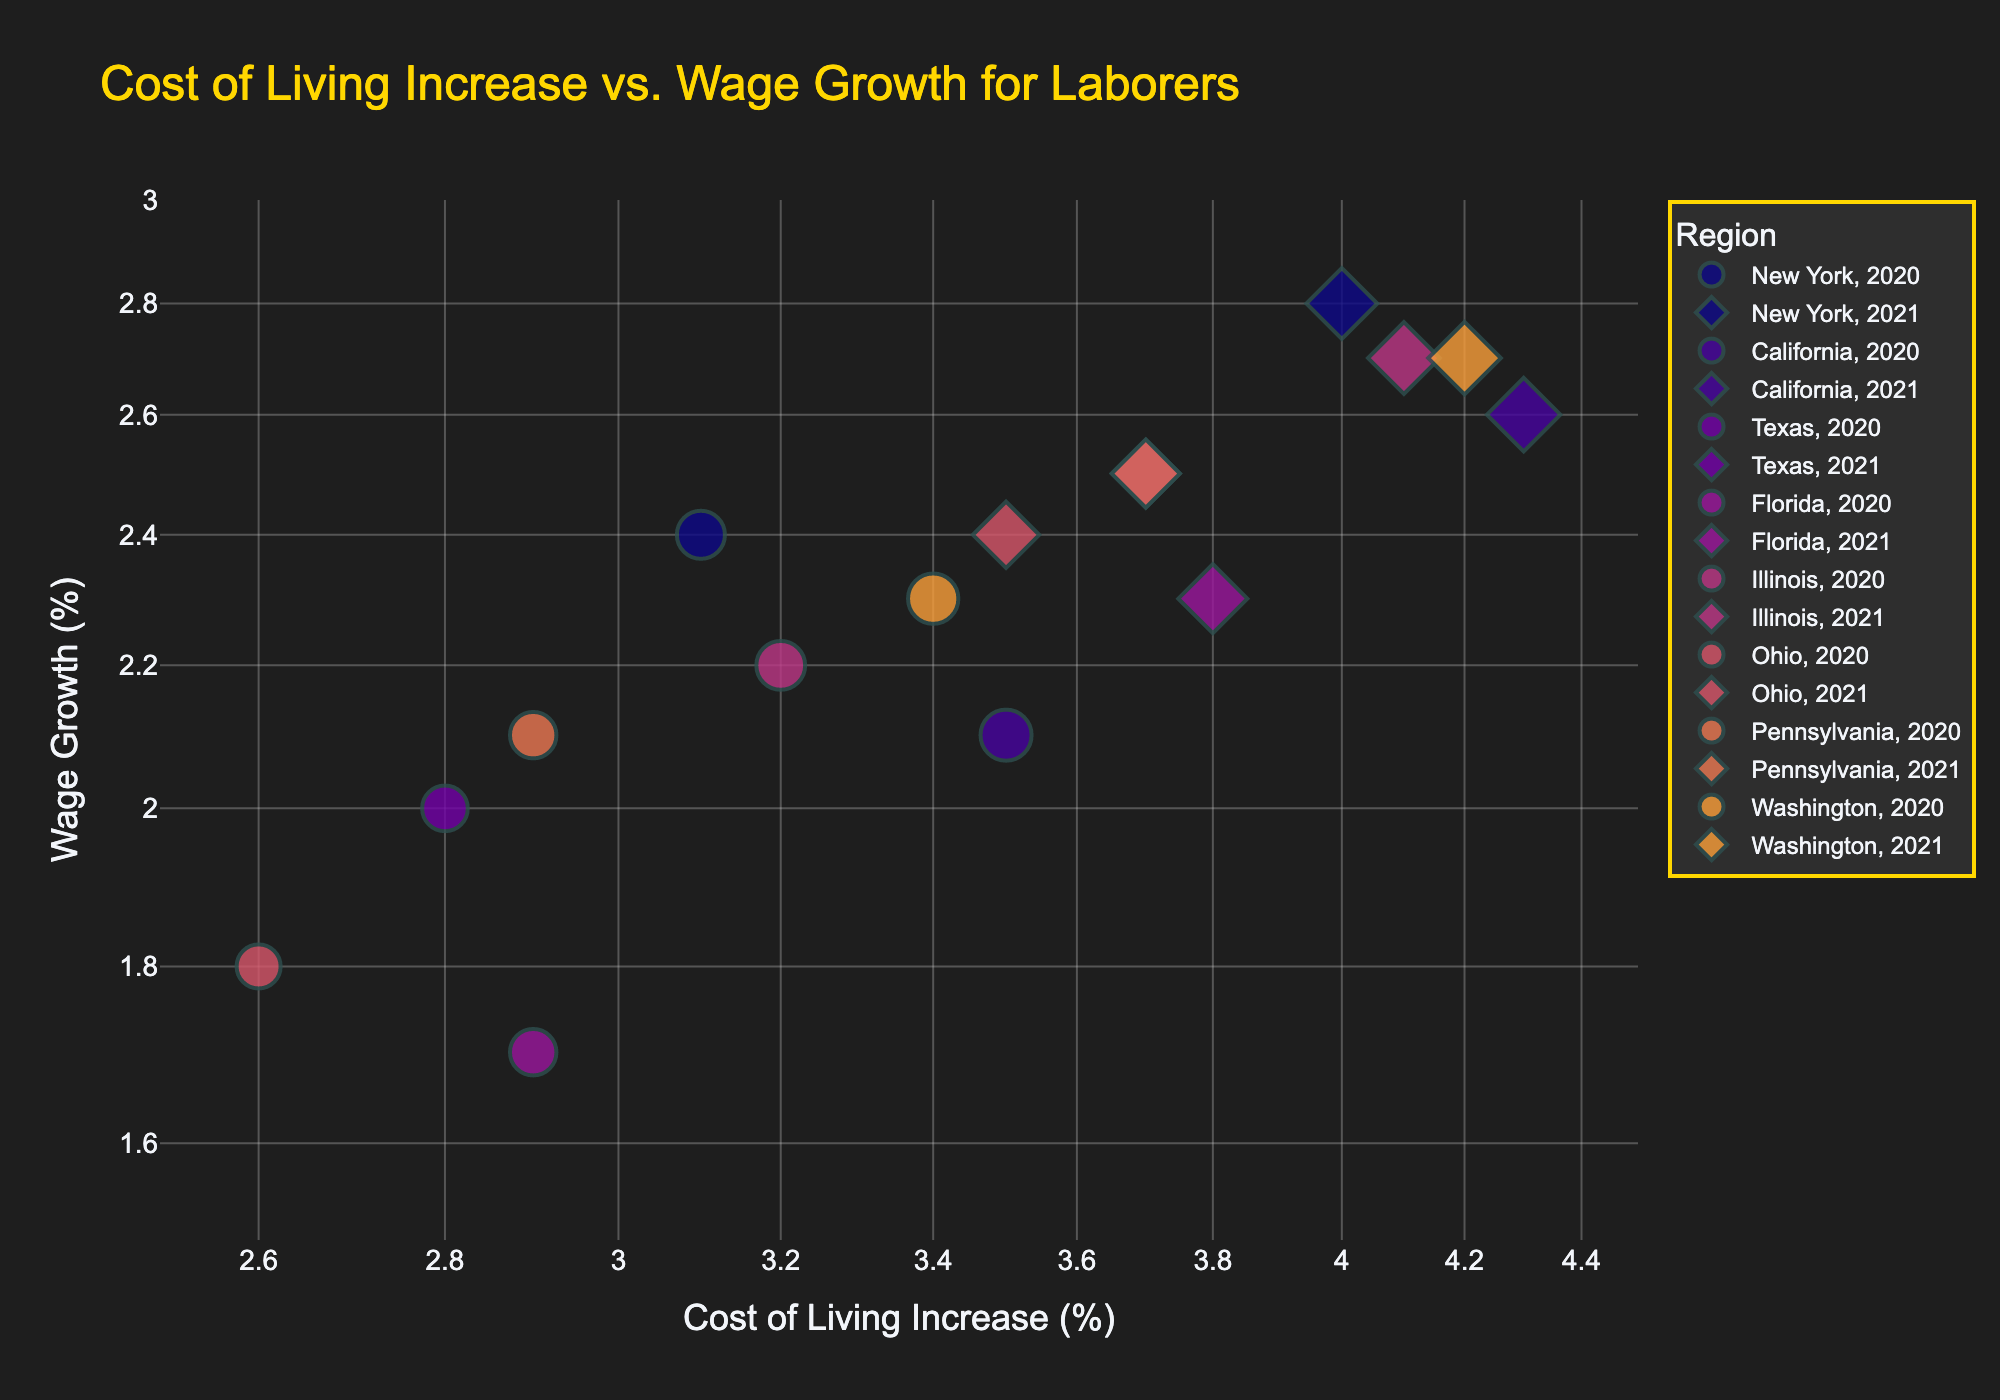What is the title of the figure? The title of the figure is prominently displayed at the top and it reads "Cost of Living Increase vs. Wage Growth for Laborers".
Answer: Cost of Living Increase vs. Wage Growth for Laborers How many different regions are represented in the figure? The legend on the right side of the figure distinctly shows the regions represented by different colors. There are seven regions identified in total.
Answer: Seven regions Which region shows the highest cost of living increase? By observing the x-axis, which represents the cost of living increase in log scale, and identifying the point furthest to the right, we see that California in 2021 has the highest cost of living increase.
Answer: California in 2021 How do wage growth and cost of living increase for New York in 2020 compare to those in 2021? For New York, locate the points for 2020 and 2021 using the symbol shape differences. In 2020, wage growth is 2.4% and cost of living increase is 3.1%. In 2021, wage growth is 2.8% and cost of living increase is 4.0%. Wages increased by 0.4%, and cost of living increased by 0.9% from 2020 to 2021.
Answer: Wage growth increased by 0.4%, cost of living increased by 0.9% Which region has the smallest difference between cost of living increase and wage growth in 2021? Evaluate the vertical distance between data points along the y-axis for each region in 2021. Shorter distances indicate smaller differences. Texas in 2021 shows the smallest difference, with cost of living increase at 3.7% and wage growth at 2.5%. The difference is 1.2%.
Answer: Texas in 2021 What trends can be observed between wage growth and cost of living increases across the regions? By observing the overall scatter plot, regions with higher cost of living increases tend to still have wage growth below cost of living increases. All regions show points where cost of living increases consistently outpace wage growth, indicating a general trend where wages lag behind cost of living increases.
Answer: Wage growth lags behind cost of living increases across regions What is the trend in cost of living increase for California from 2020 to 2021? By locating California's data points for 2020 and 2021, observe that the cost of living increase from 2020 (3.5%) to 2021 (4.3%) shows a visible upward shift along the x-axis. The trend indicates that the cost of living increase in California has risen.
Answer: Increased by 0.8% Is there any annotation on the figure? What does it indicate? There is an annotation near the middle of the plot, around 3.5% cost of living increase and 2% wage growth. It highlights the gap between cost of living increase and wage growth, emphasizing the disparity where cost of living increases are generally higher than wage growth.
Answer: Annotation indicates the gap between cost of living increase and wage growth Which year shows higher wage growth for most regions? Comparing points with different symbols for years across all regions, the 2021 data points show slightly higher wage growths compared to 2020 in most cases, indicating a general trend of increased wage growth.
Answer: 2021 